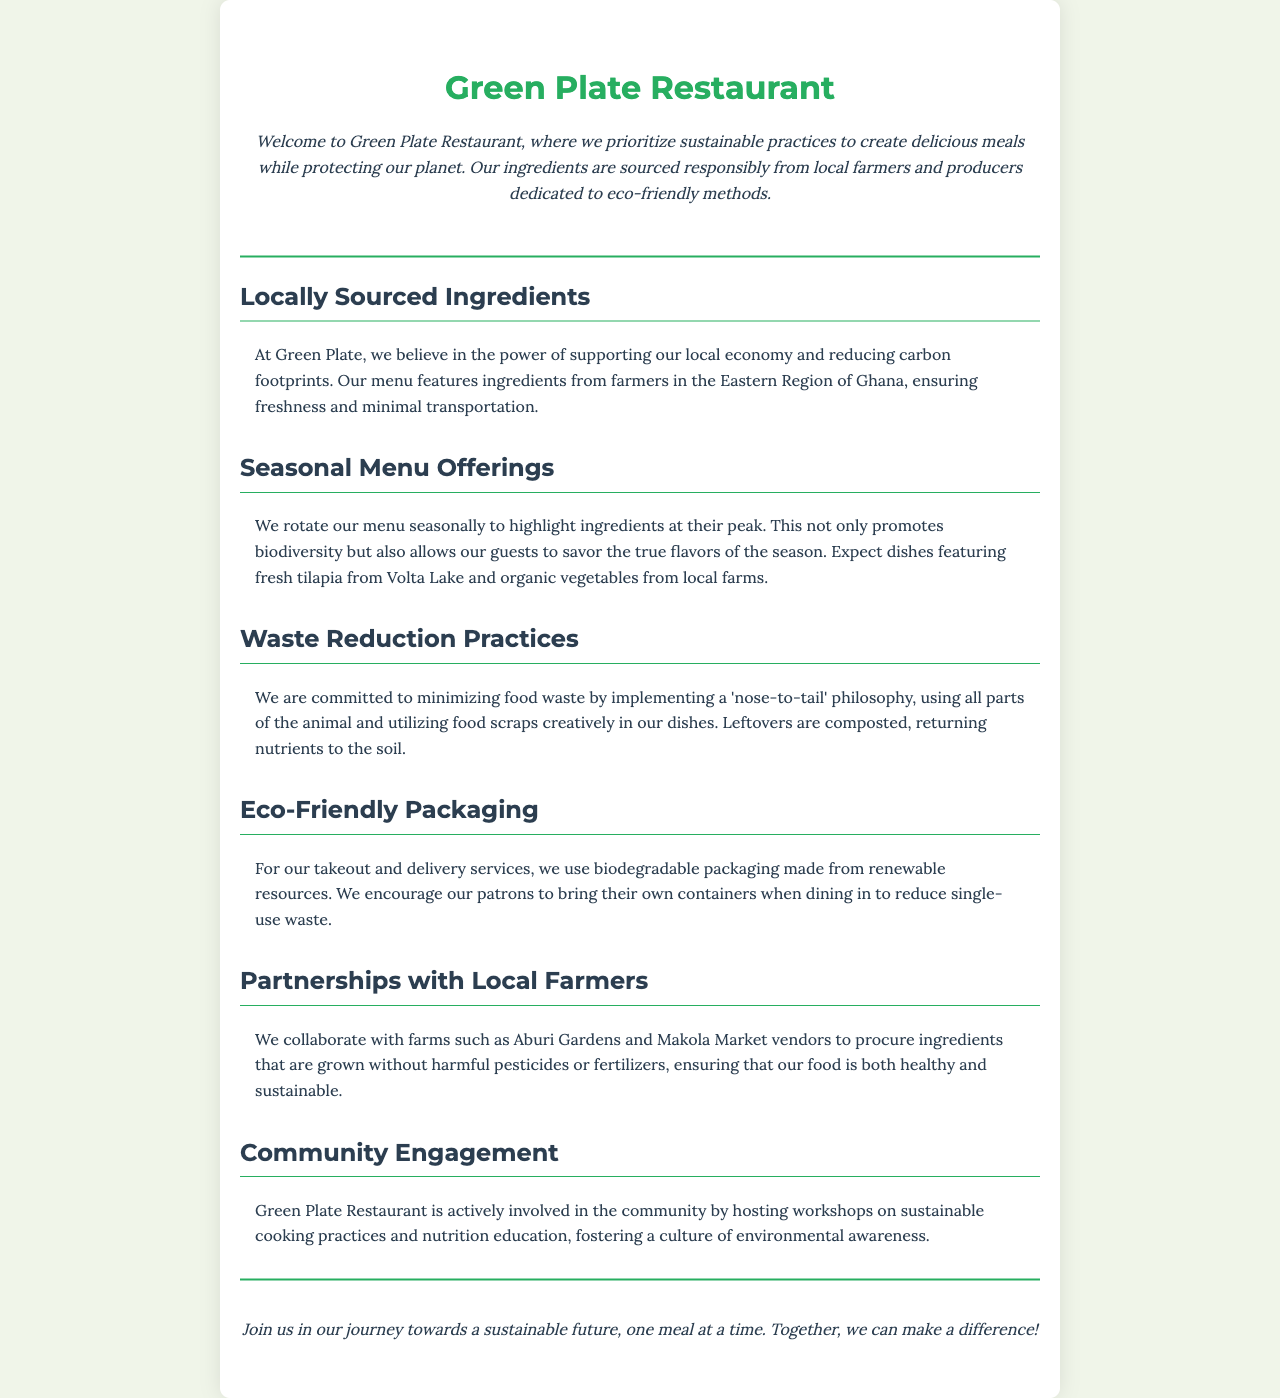What is the name of the restaurant? The name of the restaurant is mentioned in the header of the document.
Answer: Green Plate Restaurant Where are the ingredients sourced from? The document states that ingredients are sourced from local farmers in a specific region.
Answer: Eastern Region of Ghana What philosophy does the restaurant implement to reduce food waste? The document discusses a philosophy that uses all parts of the animal and creatively uses food scraps.
Answer: Nose-to-tail What type of packaging is used for takeout? The document specifies the nature of the packaging used for takeout services.
Answer: Biodegradable packaging What is one of the seasonal ingredients mentioned in the menu? The document lists seasonal offerings highlighting specific local ingredients.
Answer: Fresh tilapia Which local farms does Green Plate collaborate with? The document provides names of specific local farms with whom the restaurant collaborates.
Answer: Aburi Gardens and Makola Market vendors What community activity does Green Plate engage in? The document mentions a specific type of event the restaurant hosts for the community.
Answer: Workshops on sustainable cooking practices How does Green Plate encourage patrons to reduce waste? The document outlines a practice promoted by the restaurant to minimize waste when dining in.
Answer: Bring their own containers What type of education does Green Plate offer? The document indicates the kind of education provided in the community engagement section.
Answer: Nutrition education 